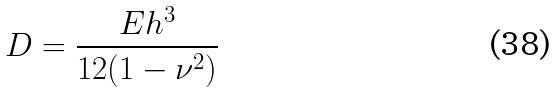Convert formula to latex. <formula><loc_0><loc_0><loc_500><loc_500>D = \frac { E h ^ { 3 } } { 1 2 ( 1 - \nu ^ { 2 } ) }</formula> 